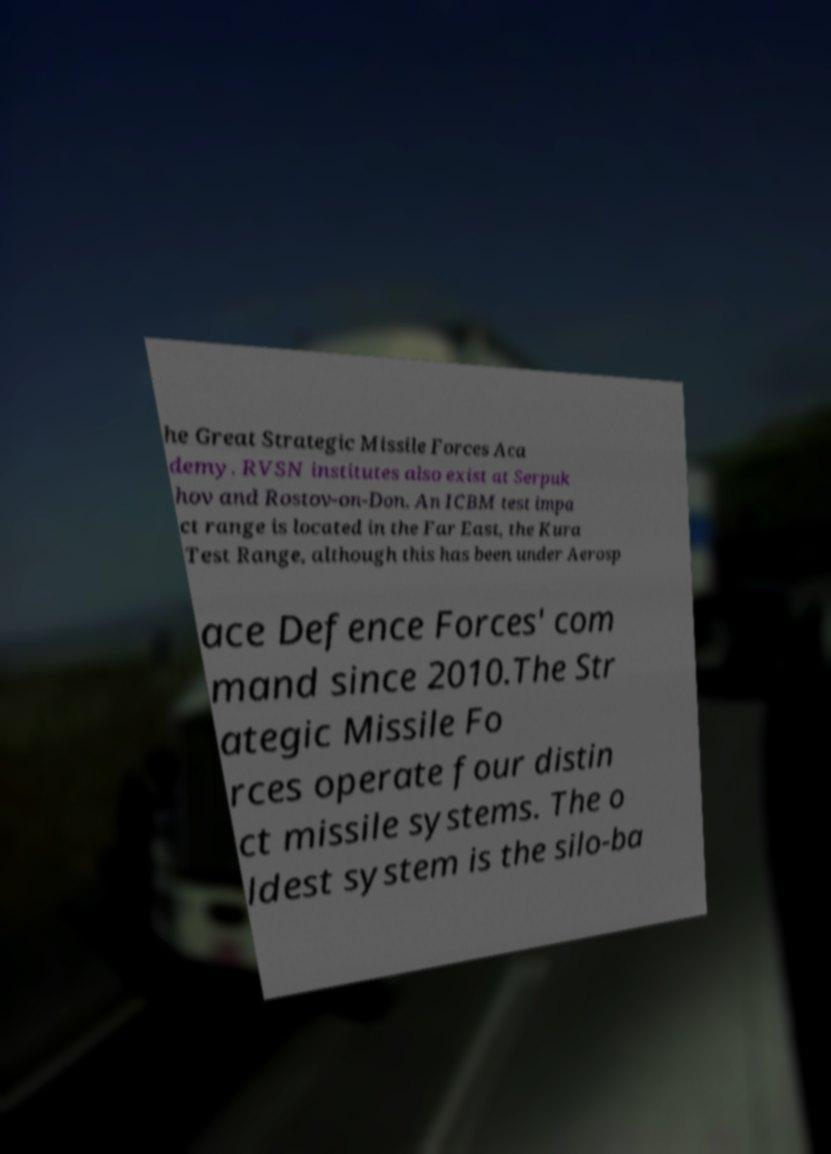Could you assist in decoding the text presented in this image and type it out clearly? he Great Strategic Missile Forces Aca demy. RVSN institutes also exist at Serpuk hov and Rostov-on-Don. An ICBM test impa ct range is located in the Far East, the Kura Test Range, although this has been under Aerosp ace Defence Forces' com mand since 2010.The Str ategic Missile Fo rces operate four distin ct missile systems. The o ldest system is the silo-ba 